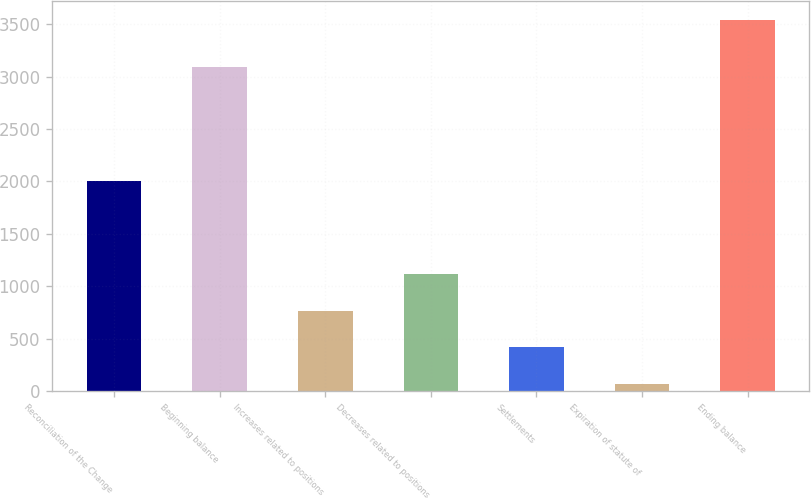Convert chart to OTSL. <chart><loc_0><loc_0><loc_500><loc_500><bar_chart><fcel>Reconciliation of the Change<fcel>Beginning balance<fcel>Increases related to positions<fcel>Decreases related to positions<fcel>Settlements<fcel>Expiration of statute of<fcel>Ending balance<nl><fcel>2008<fcel>3095<fcel>765.8<fcel>1112.7<fcel>418.9<fcel>72<fcel>3541<nl></chart> 